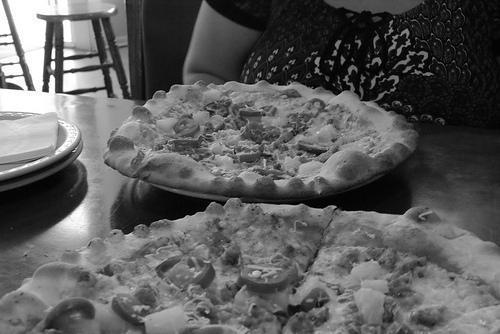How many pizzas are there?
Give a very brief answer. 2. 